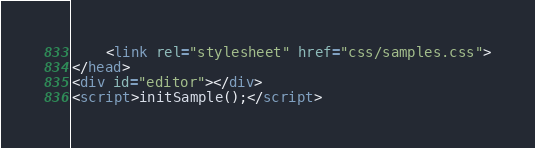<code> <loc_0><loc_0><loc_500><loc_500><_HTML_>	<link rel="stylesheet" href="css/samples.css">
</head>
<div id="editor"></div>
<script>initSample();</script>
</code> 